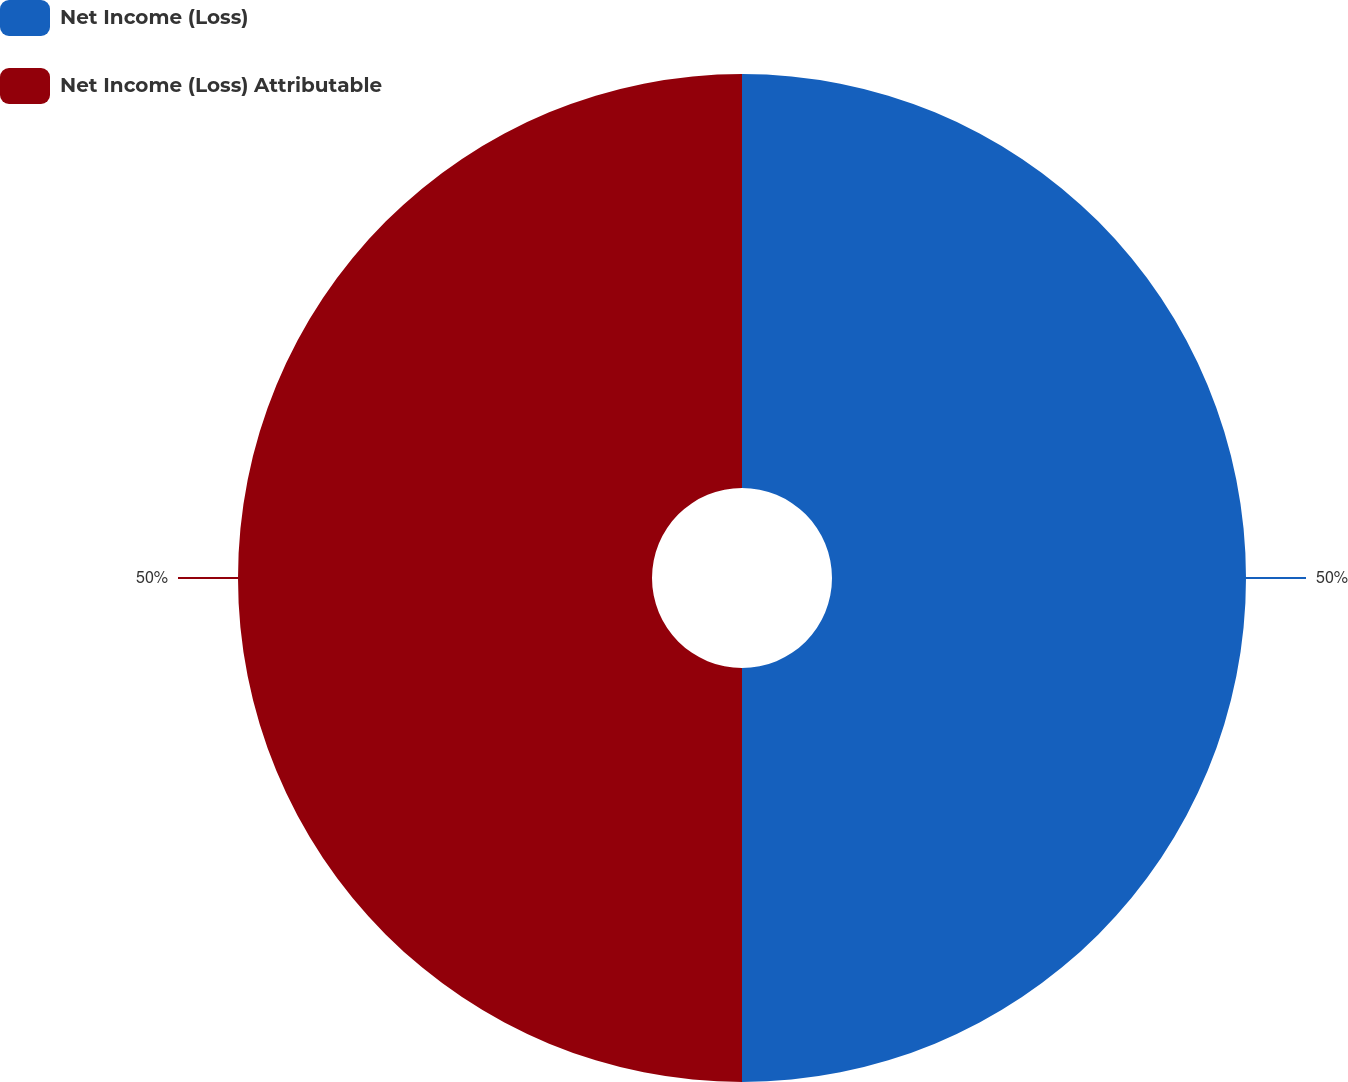Convert chart. <chart><loc_0><loc_0><loc_500><loc_500><pie_chart><fcel>Net Income (Loss)<fcel>Net Income (Loss) Attributable<nl><fcel>50.0%<fcel>50.0%<nl></chart> 